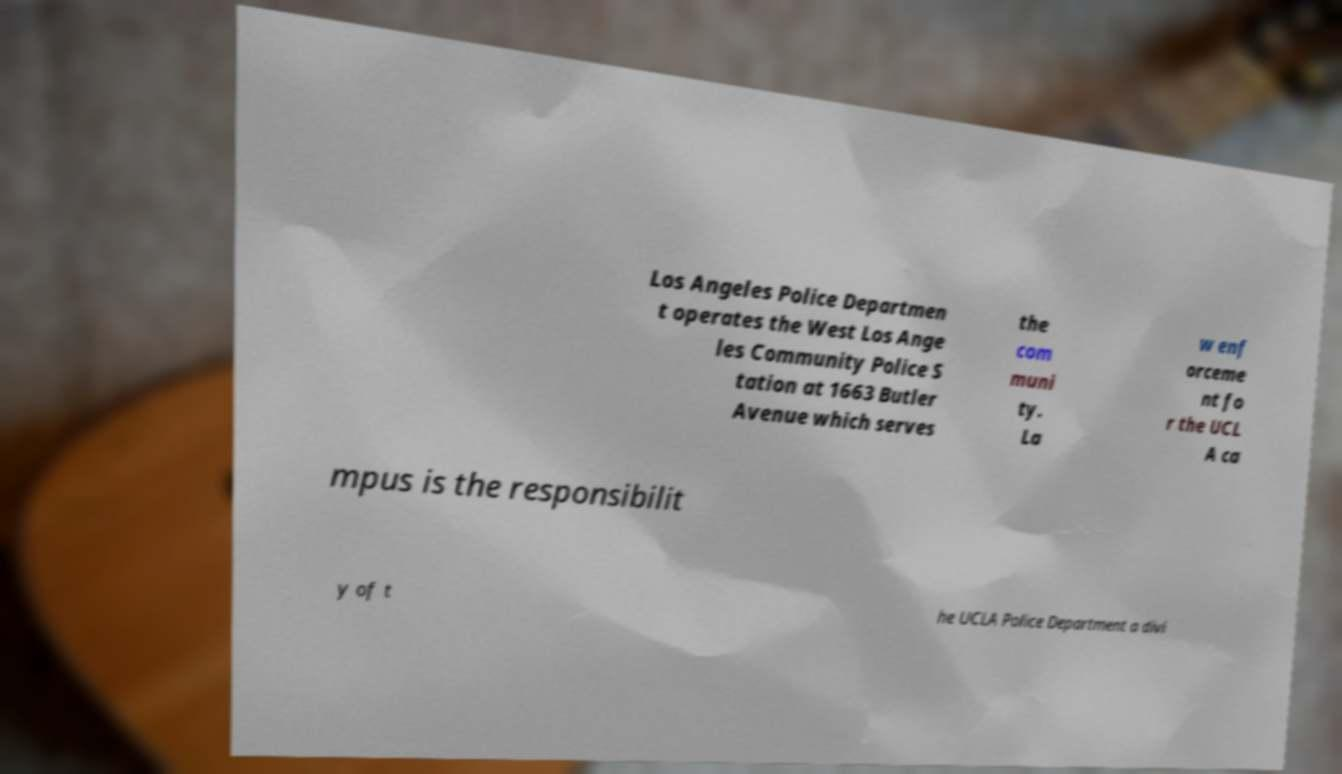Could you extract and type out the text from this image? Los Angeles Police Departmen t operates the West Los Ange les Community Police S tation at 1663 Butler Avenue which serves the com muni ty. La w enf orceme nt fo r the UCL A ca mpus is the responsibilit y of t he UCLA Police Department a divi 